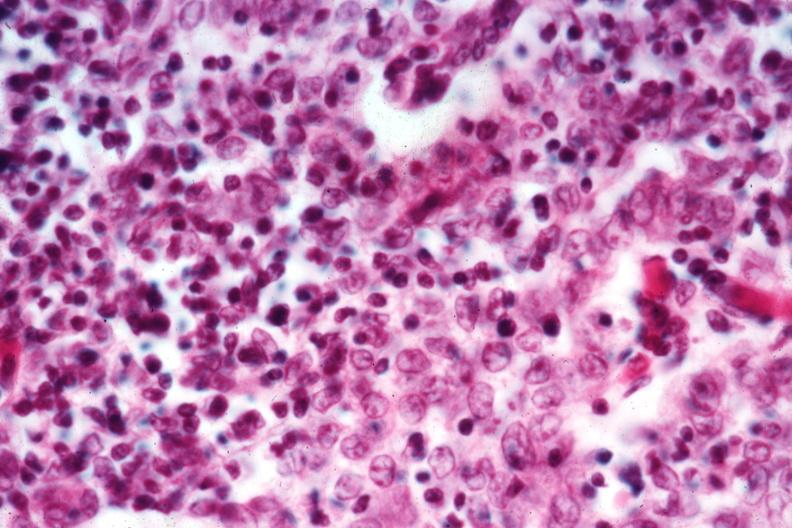s krukenberg tumor present?
Answer the question using a single word or phrase. No 